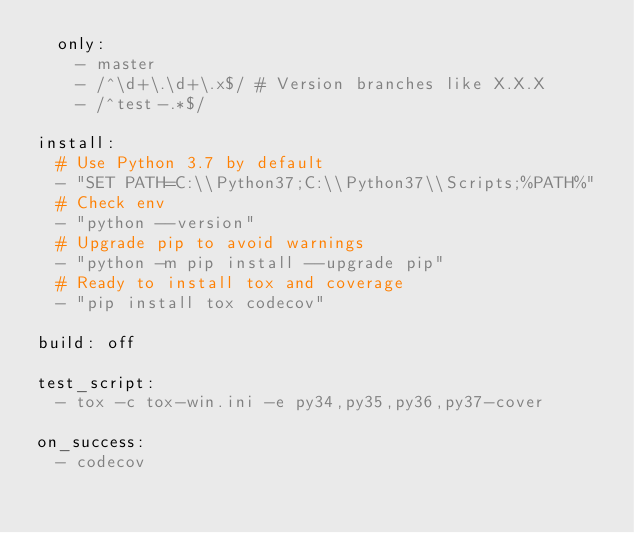Convert code to text. <code><loc_0><loc_0><loc_500><loc_500><_YAML_>  only:
    - master
    - /^\d+\.\d+\.x$/ # Version branches like X.X.X
    - /^test-.*$/

install:
  # Use Python 3.7 by default
  - "SET PATH=C:\\Python37;C:\\Python37\\Scripts;%PATH%"
  # Check env
  - "python --version"
  # Upgrade pip to avoid warnings
  - "python -m pip install --upgrade pip"
  # Ready to install tox and coverage
  - "pip install tox codecov"

build: off

test_script:
  - tox -c tox-win.ini -e py34,py35,py36,py37-cover

on_success:
  - codecov
</code> 